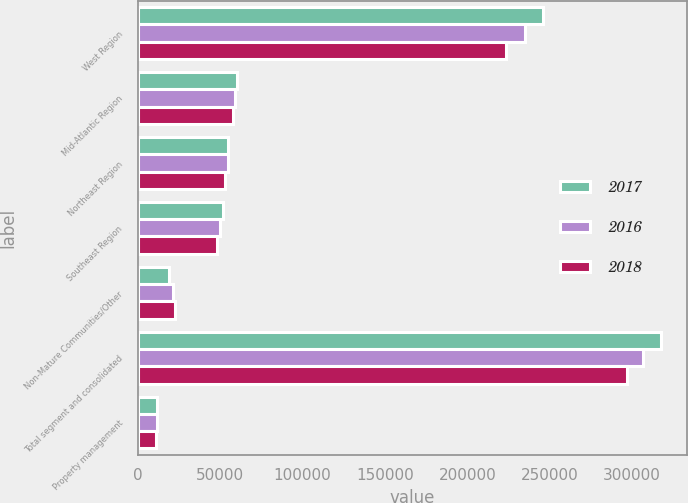Convert chart. <chart><loc_0><loc_0><loc_500><loc_500><stacked_bar_chart><ecel><fcel>West Region<fcel>Mid-Atlantic Region<fcel>Northeast Region<fcel>Southeast Region<fcel>Non-Mature Communities/Other<fcel>Total segment and consolidated<fcel>Property management<nl><fcel>2017<fcel>246047<fcel>60389<fcel>54749<fcel>51896<fcel>18839<fcel>317380<fcel>11878<nl><fcel>2016<fcel>235022<fcel>59006<fcel>54530<fcel>49586<fcel>21233<fcel>306841<fcel>11533<nl><fcel>2018<fcel>223539<fcel>57563<fcel>53036<fcel>47792<fcel>22485<fcel>297121<fcel>11122<nl></chart> 